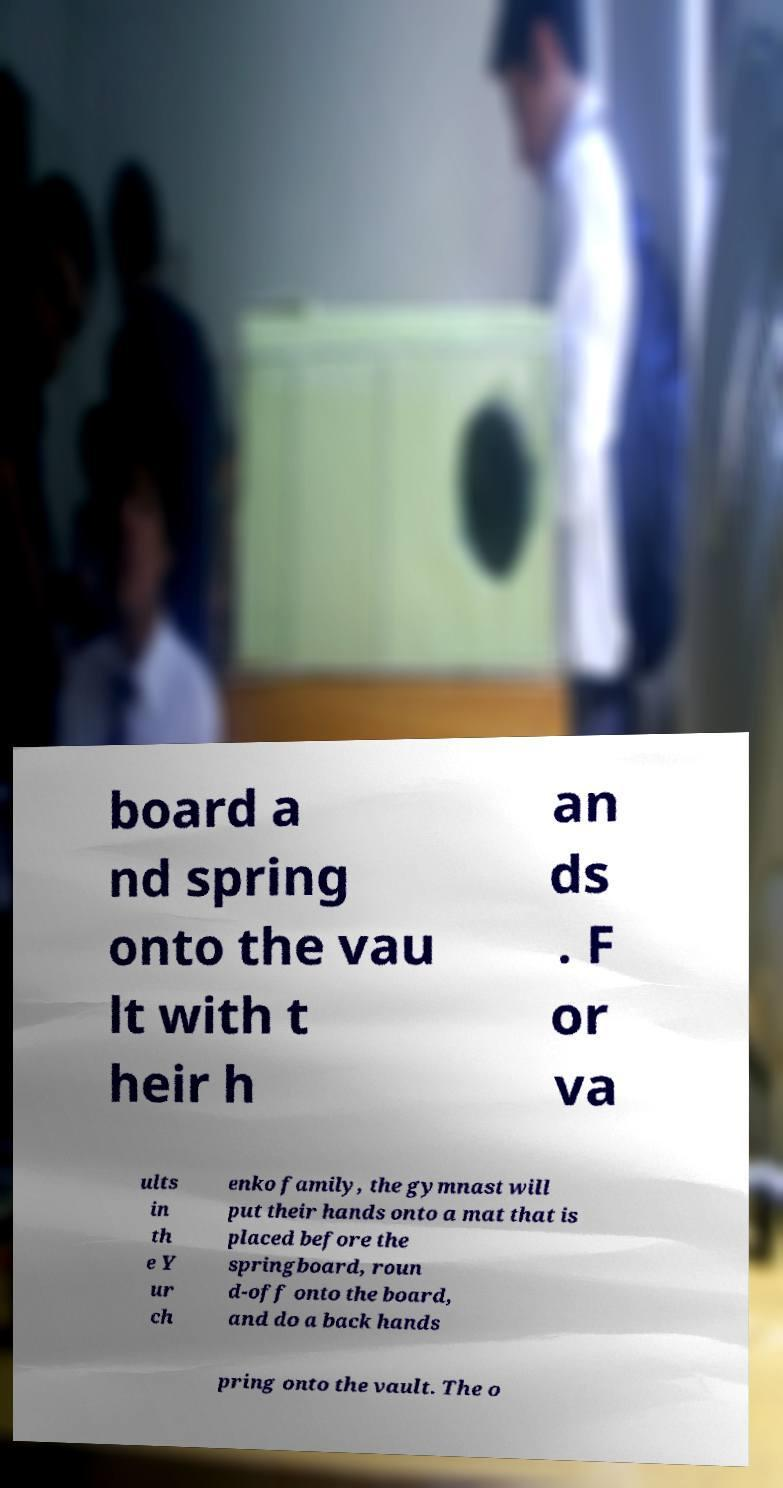I need the written content from this picture converted into text. Can you do that? board a nd spring onto the vau lt with t heir h an ds . F or va ults in th e Y ur ch enko family, the gymnast will put their hands onto a mat that is placed before the springboard, roun d-off onto the board, and do a back hands pring onto the vault. The o 